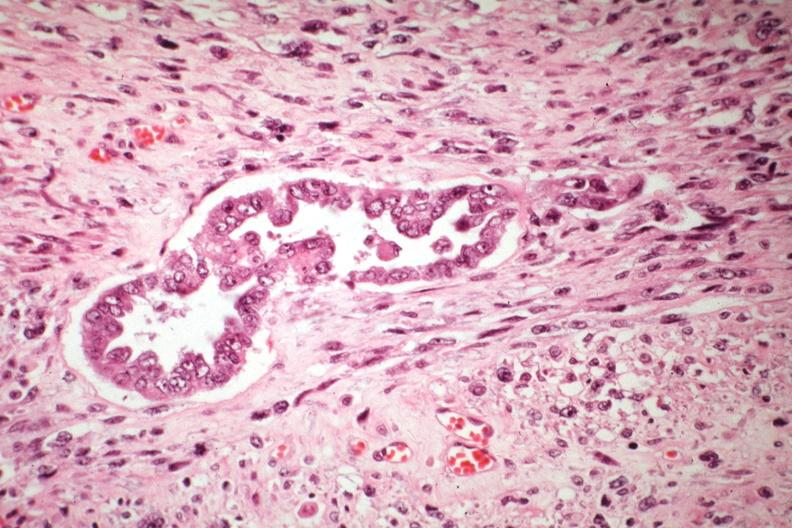s rheumatoid arthritis present?
Answer the question using a single word or phrase. No 